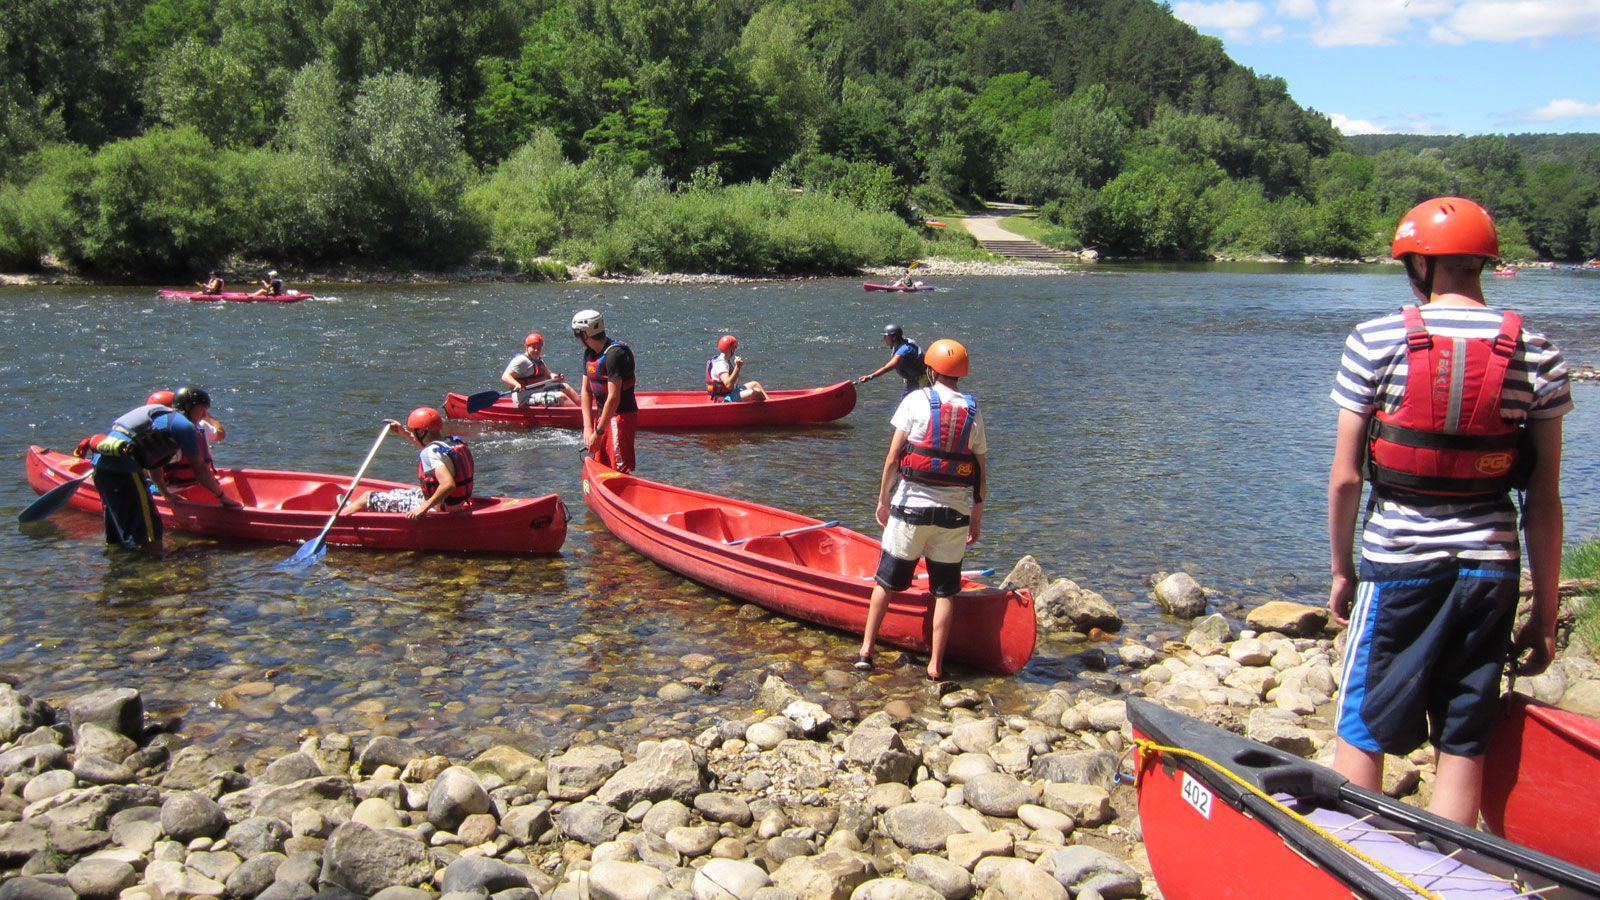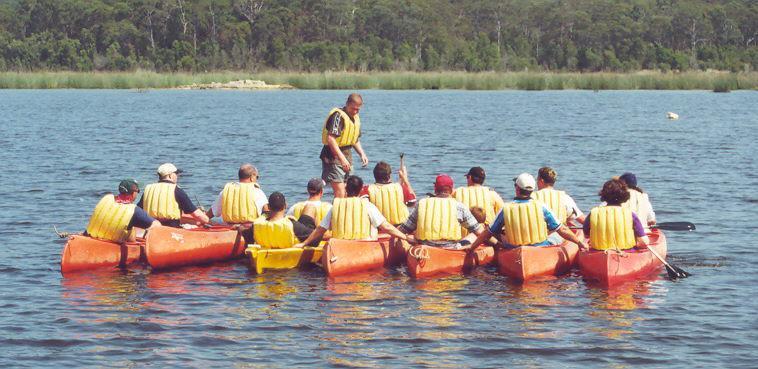The first image is the image on the left, the second image is the image on the right. Analyze the images presented: Is the assertion "The left image includes a person standing by an empty canoe that is pulled up to the water's edge, with at least one other canoe on the water in the background." valid? Answer yes or no. Yes. The first image is the image on the left, the second image is the image on the right. Considering the images on both sides, is "All the boats are in the water." valid? Answer yes or no. No. 